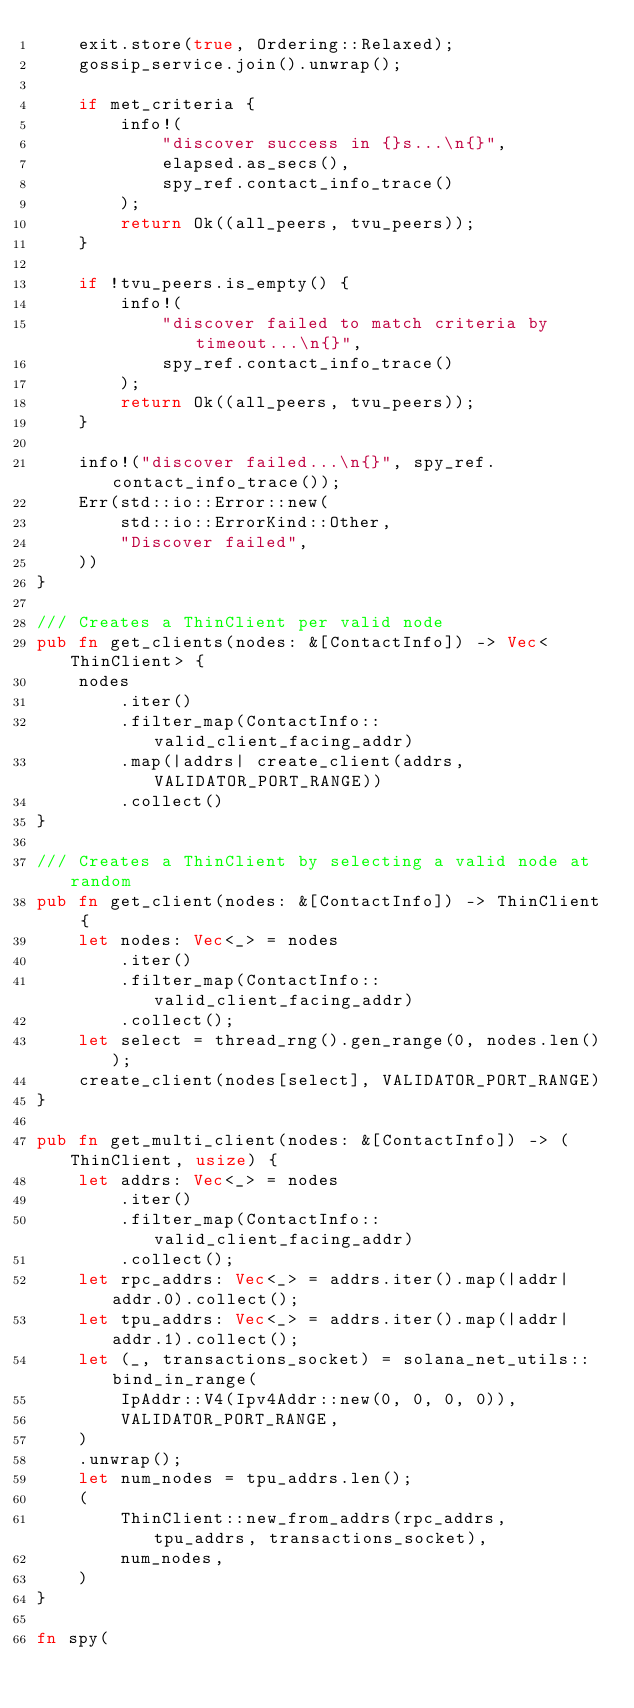<code> <loc_0><loc_0><loc_500><loc_500><_Rust_>    exit.store(true, Ordering::Relaxed);
    gossip_service.join().unwrap();

    if met_criteria {
        info!(
            "discover success in {}s...\n{}",
            elapsed.as_secs(),
            spy_ref.contact_info_trace()
        );
        return Ok((all_peers, tvu_peers));
    }

    if !tvu_peers.is_empty() {
        info!(
            "discover failed to match criteria by timeout...\n{}",
            spy_ref.contact_info_trace()
        );
        return Ok((all_peers, tvu_peers));
    }

    info!("discover failed...\n{}", spy_ref.contact_info_trace());
    Err(std::io::Error::new(
        std::io::ErrorKind::Other,
        "Discover failed",
    ))
}

/// Creates a ThinClient per valid node
pub fn get_clients(nodes: &[ContactInfo]) -> Vec<ThinClient> {
    nodes
        .iter()
        .filter_map(ContactInfo::valid_client_facing_addr)
        .map(|addrs| create_client(addrs, VALIDATOR_PORT_RANGE))
        .collect()
}

/// Creates a ThinClient by selecting a valid node at random
pub fn get_client(nodes: &[ContactInfo]) -> ThinClient {
    let nodes: Vec<_> = nodes
        .iter()
        .filter_map(ContactInfo::valid_client_facing_addr)
        .collect();
    let select = thread_rng().gen_range(0, nodes.len());
    create_client(nodes[select], VALIDATOR_PORT_RANGE)
}

pub fn get_multi_client(nodes: &[ContactInfo]) -> (ThinClient, usize) {
    let addrs: Vec<_> = nodes
        .iter()
        .filter_map(ContactInfo::valid_client_facing_addr)
        .collect();
    let rpc_addrs: Vec<_> = addrs.iter().map(|addr| addr.0).collect();
    let tpu_addrs: Vec<_> = addrs.iter().map(|addr| addr.1).collect();
    let (_, transactions_socket) = solana_net_utils::bind_in_range(
        IpAddr::V4(Ipv4Addr::new(0, 0, 0, 0)),
        VALIDATOR_PORT_RANGE,
    )
    .unwrap();
    let num_nodes = tpu_addrs.len();
    (
        ThinClient::new_from_addrs(rpc_addrs, tpu_addrs, transactions_socket),
        num_nodes,
    )
}

fn spy(</code> 